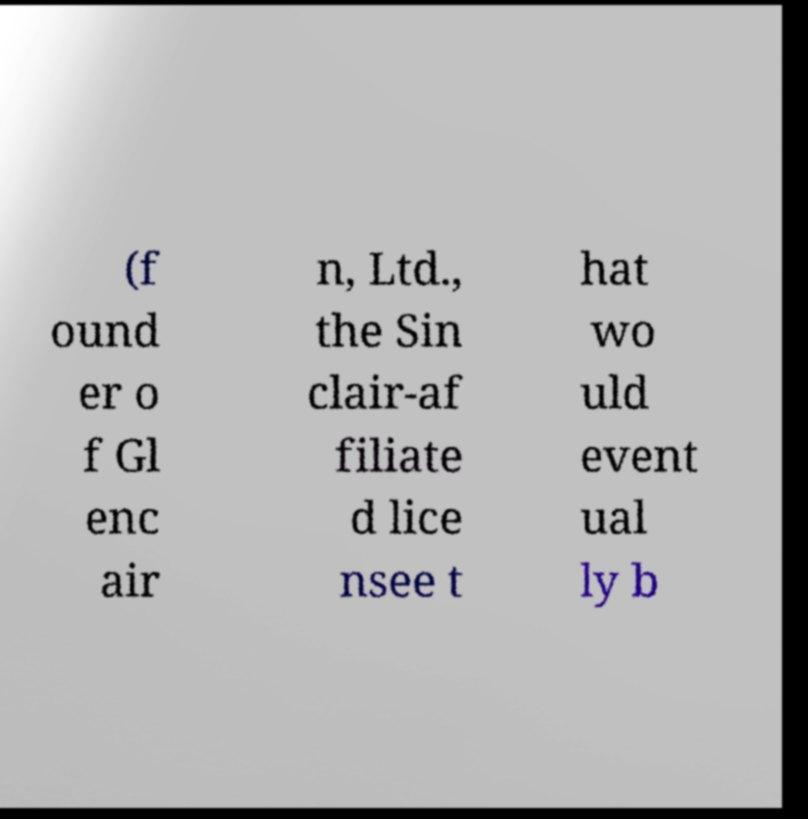Could you assist in decoding the text presented in this image and type it out clearly? (f ound er o f Gl enc air n, Ltd., the Sin clair-af filiate d lice nsee t hat wo uld event ual ly b 